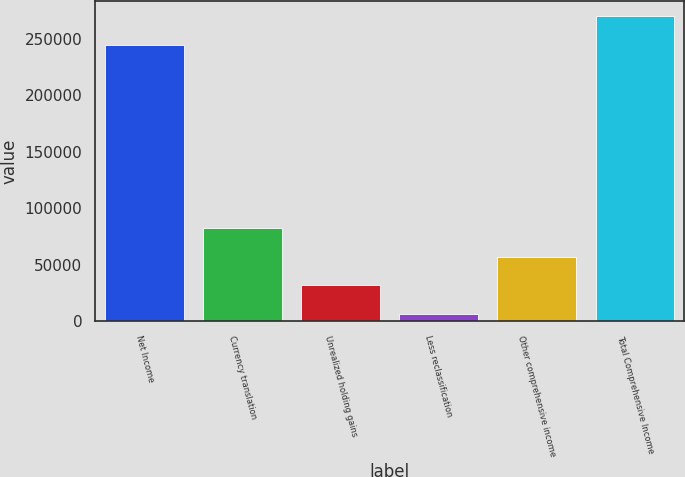Convert chart to OTSL. <chart><loc_0><loc_0><loc_500><loc_500><bar_chart><fcel>Net Income<fcel>Currency translation<fcel>Unrealized holding gains<fcel>Less reclassification<fcel>Other comprehensive income<fcel>Total Comprehensive Income<nl><fcel>244934<fcel>82252.4<fcel>31892.8<fcel>6713<fcel>57072.6<fcel>270114<nl></chart> 